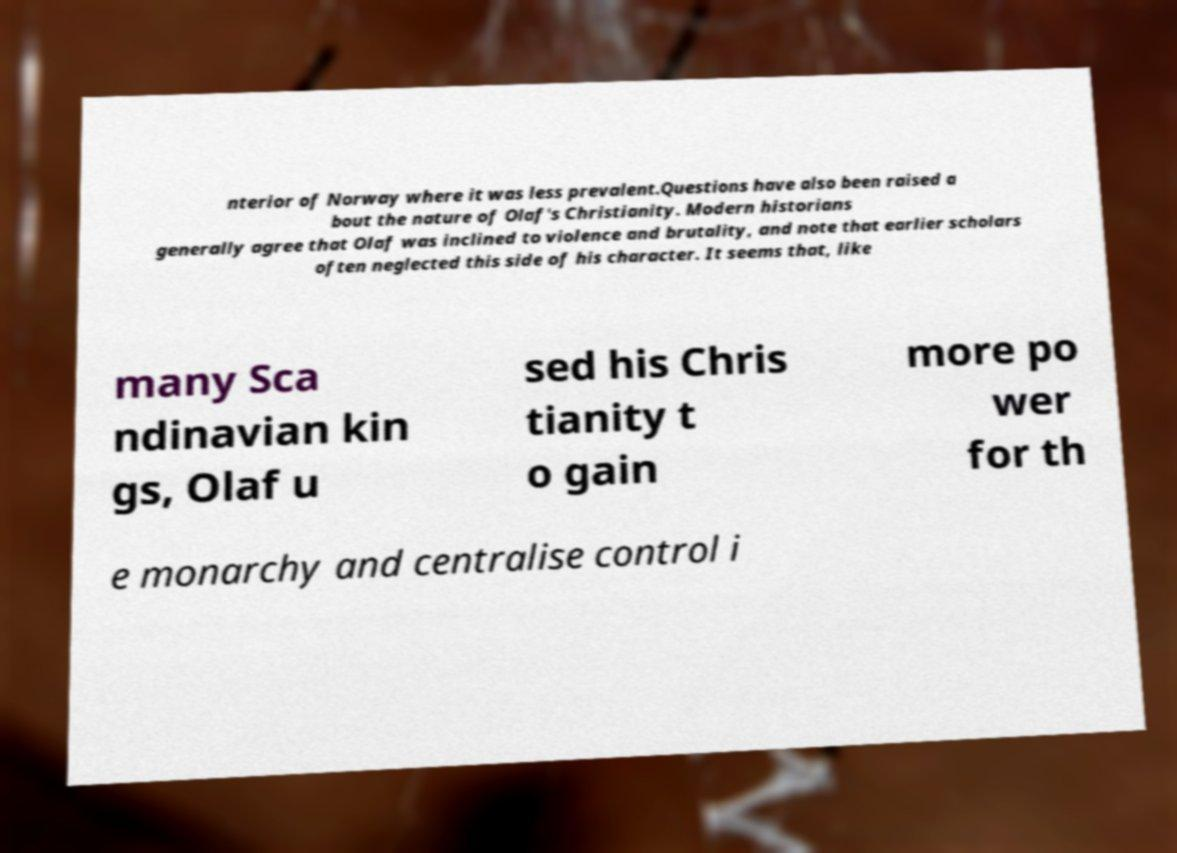I need the written content from this picture converted into text. Can you do that? nterior of Norway where it was less prevalent.Questions have also been raised a bout the nature of Olaf's Christianity. Modern historians generally agree that Olaf was inclined to violence and brutality, and note that earlier scholars often neglected this side of his character. It seems that, like many Sca ndinavian kin gs, Olaf u sed his Chris tianity t o gain more po wer for th e monarchy and centralise control i 